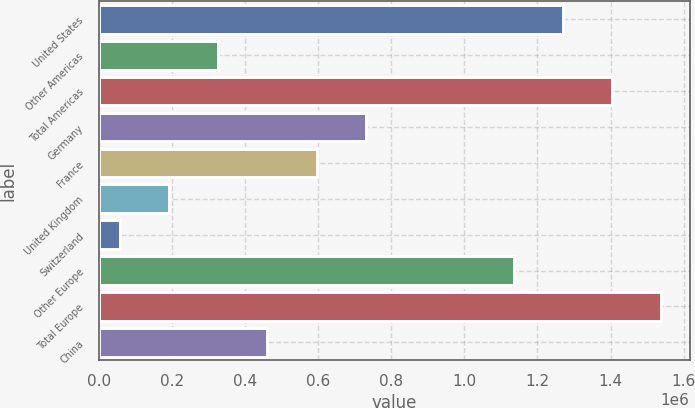Convert chart to OTSL. <chart><loc_0><loc_0><loc_500><loc_500><bar_chart><fcel>United States<fcel>Other Americas<fcel>Total Americas<fcel>Germany<fcel>France<fcel>United Kingdom<fcel>Switzerland<fcel>Other Europe<fcel>Total Europe<fcel>China<nl><fcel>1.26968e+06<fcel>326226<fcel>1.40445e+06<fcel>730562<fcel>595783<fcel>191448<fcel>56669<fcel>1.1349e+06<fcel>1.53923e+06<fcel>461004<nl></chart> 